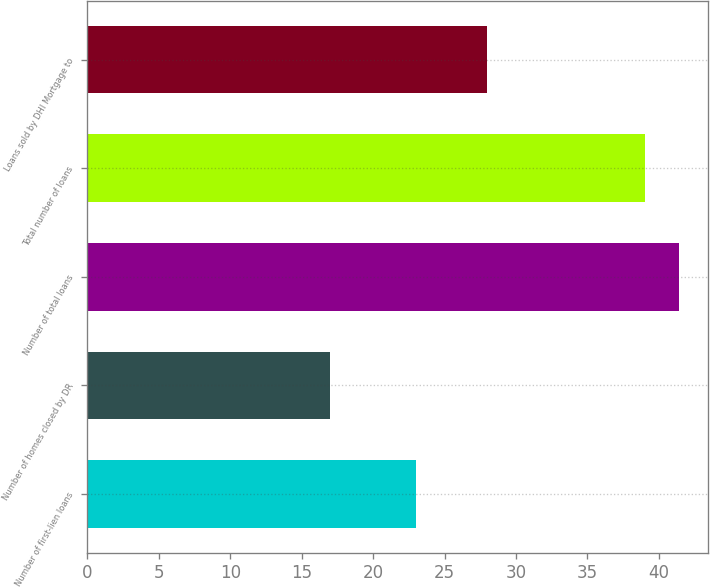<chart> <loc_0><loc_0><loc_500><loc_500><bar_chart><fcel>Number of first-lien loans<fcel>Number of homes closed by DR<fcel>Number of total loans<fcel>Total number of loans<fcel>Loans sold by DHI Mortgage to<nl><fcel>23<fcel>17<fcel>41.4<fcel>39<fcel>28<nl></chart> 